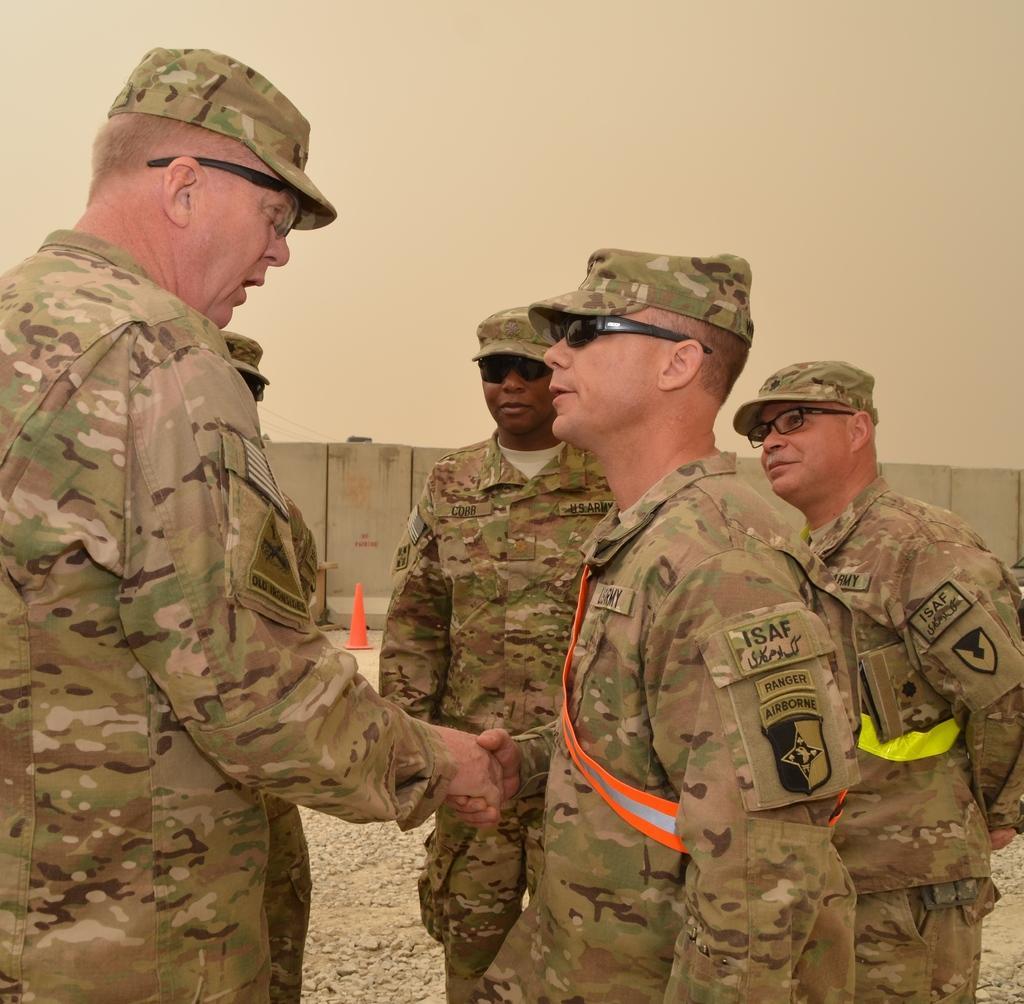Describe this image in one or two sentences. In this picture I can see some army persons who are wearing the cap, shirt and goggles. In the back I can see the concrete wall, beside that there is a traffic cone. 